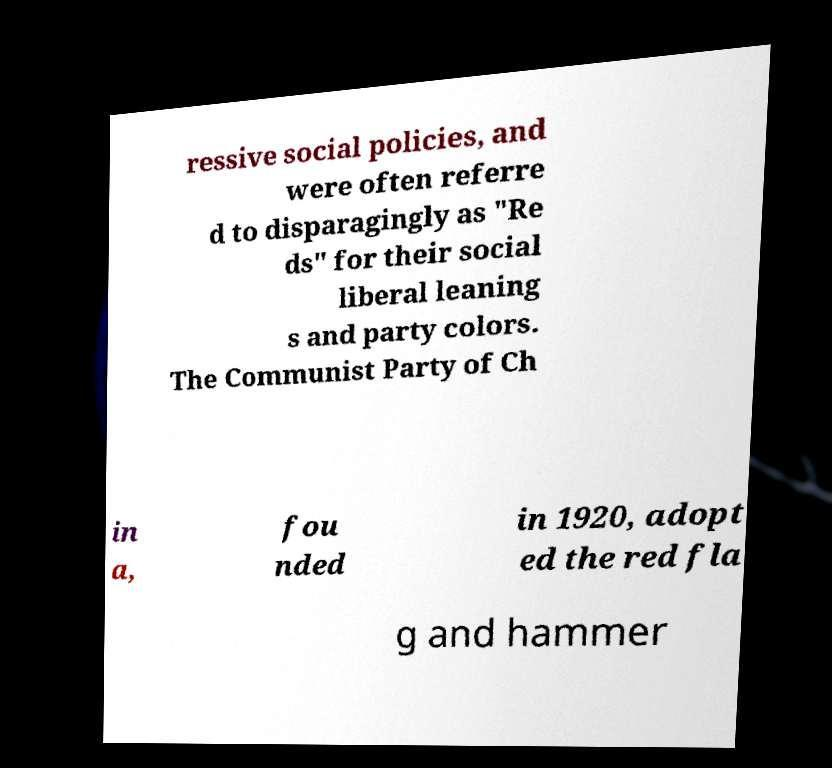What messages or text are displayed in this image? I need them in a readable, typed format. ressive social policies, and were often referre d to disparagingly as "Re ds" for their social liberal leaning s and party colors. The Communist Party of Ch in a, fou nded in 1920, adopt ed the red fla g and hammer 